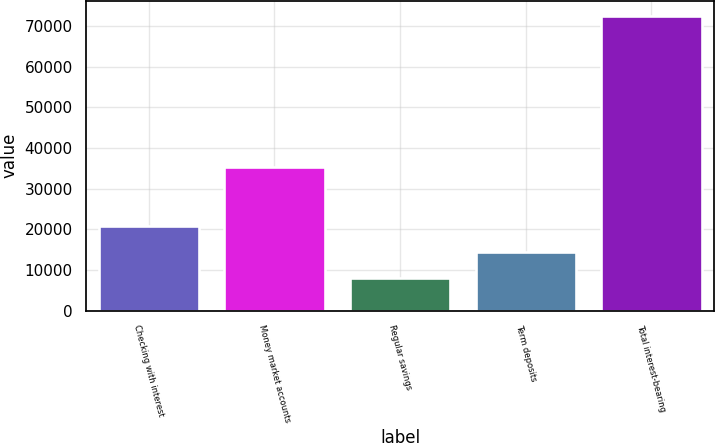Convert chart. <chart><loc_0><loc_0><loc_500><loc_500><bar_chart><fcel>Checking with interest<fcel>Money market accounts<fcel>Regular savings<fcel>Term deposits<fcel>Total interest-bearing<nl><fcel>20955.2<fcel>35401<fcel>8057<fcel>14506.1<fcel>72548<nl></chart> 